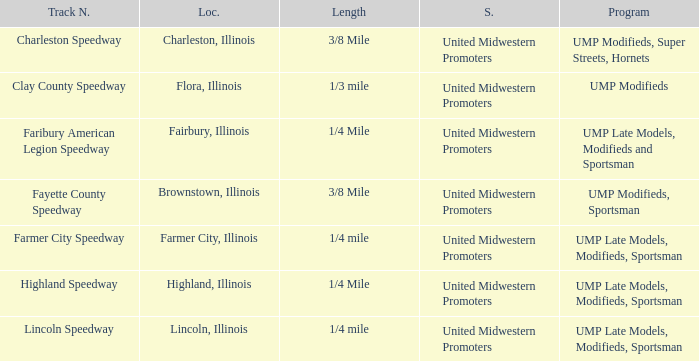Who sanctioned the event at fayette county speedway? United Midwestern Promoters. 